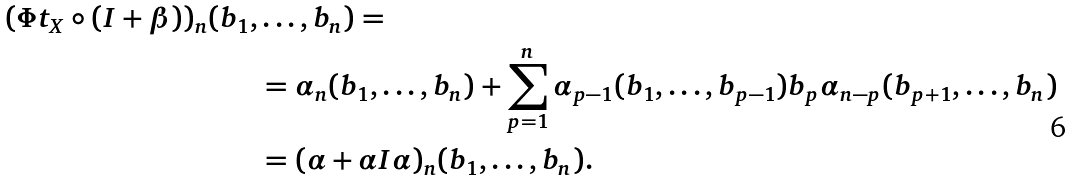Convert formula to latex. <formula><loc_0><loc_0><loc_500><loc_500>( \Phi t _ { X } \circ ( I + \beta ) ) _ { n } ( b _ { 1 } , & \dots , b _ { n } ) = \\ & = \alpha _ { n } ( b _ { 1 } , \dots , b _ { n } ) + \sum _ { p = 1 } ^ { n } \alpha _ { p - 1 } ( b _ { 1 } , \dots , b _ { p - 1 } ) b _ { p } \alpha _ { n - p } ( b _ { p + 1 } , \dots , b _ { n } ) \\ & = ( \alpha + \alpha I \alpha ) _ { n } ( b _ { 1 } , \dots , b _ { n } ) .</formula> 